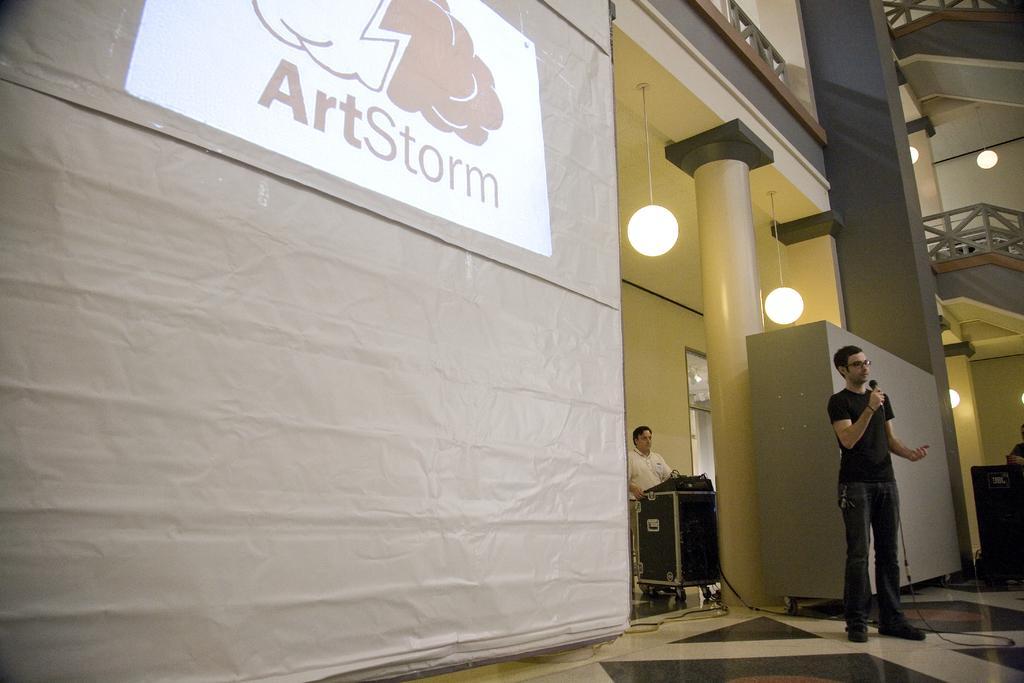Please provide a concise description of this image. On the left side of the image there is a screen with a logo and some text on it. In the background, there is a wall, pillars, lights, two persons and a few other objects. Among them, we can see one person is holding a microphone. 